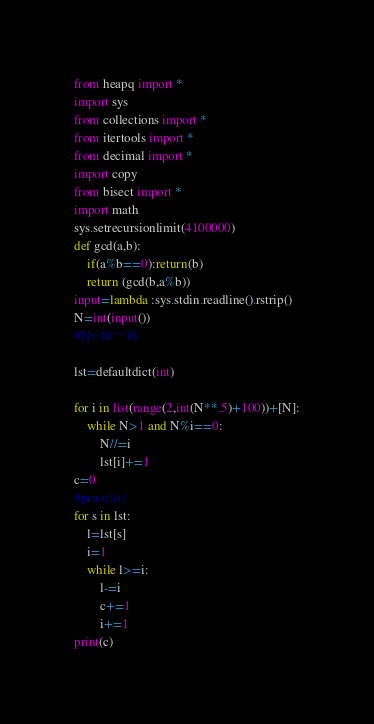Convert code to text. <code><loc_0><loc_0><loc_500><loc_500><_Python_>from heapq import *
import sys
from collections import *
from itertools import *
from decimal import *
import copy
from bisect import *
import math
sys.setrecursionlimit(4100000)
def gcd(a,b):
    if(a%b==0):return(b)
    return (gcd(b,a%b))
input=lambda :sys.stdin.readline().rstrip()
N=int(input())
#N=10**18

lst=defaultdict(int)

for i in list(range(2,int(N**.5)+100))+[N]:
    while N>1 and N%i==0:
        N//=i
        lst[i]+=1
c=0
#print(lst)
for s in lst:
    l=lst[s]
    i=1
    while l>=i:
        l-=i
        c+=1
        i+=1
print(c)
</code> 